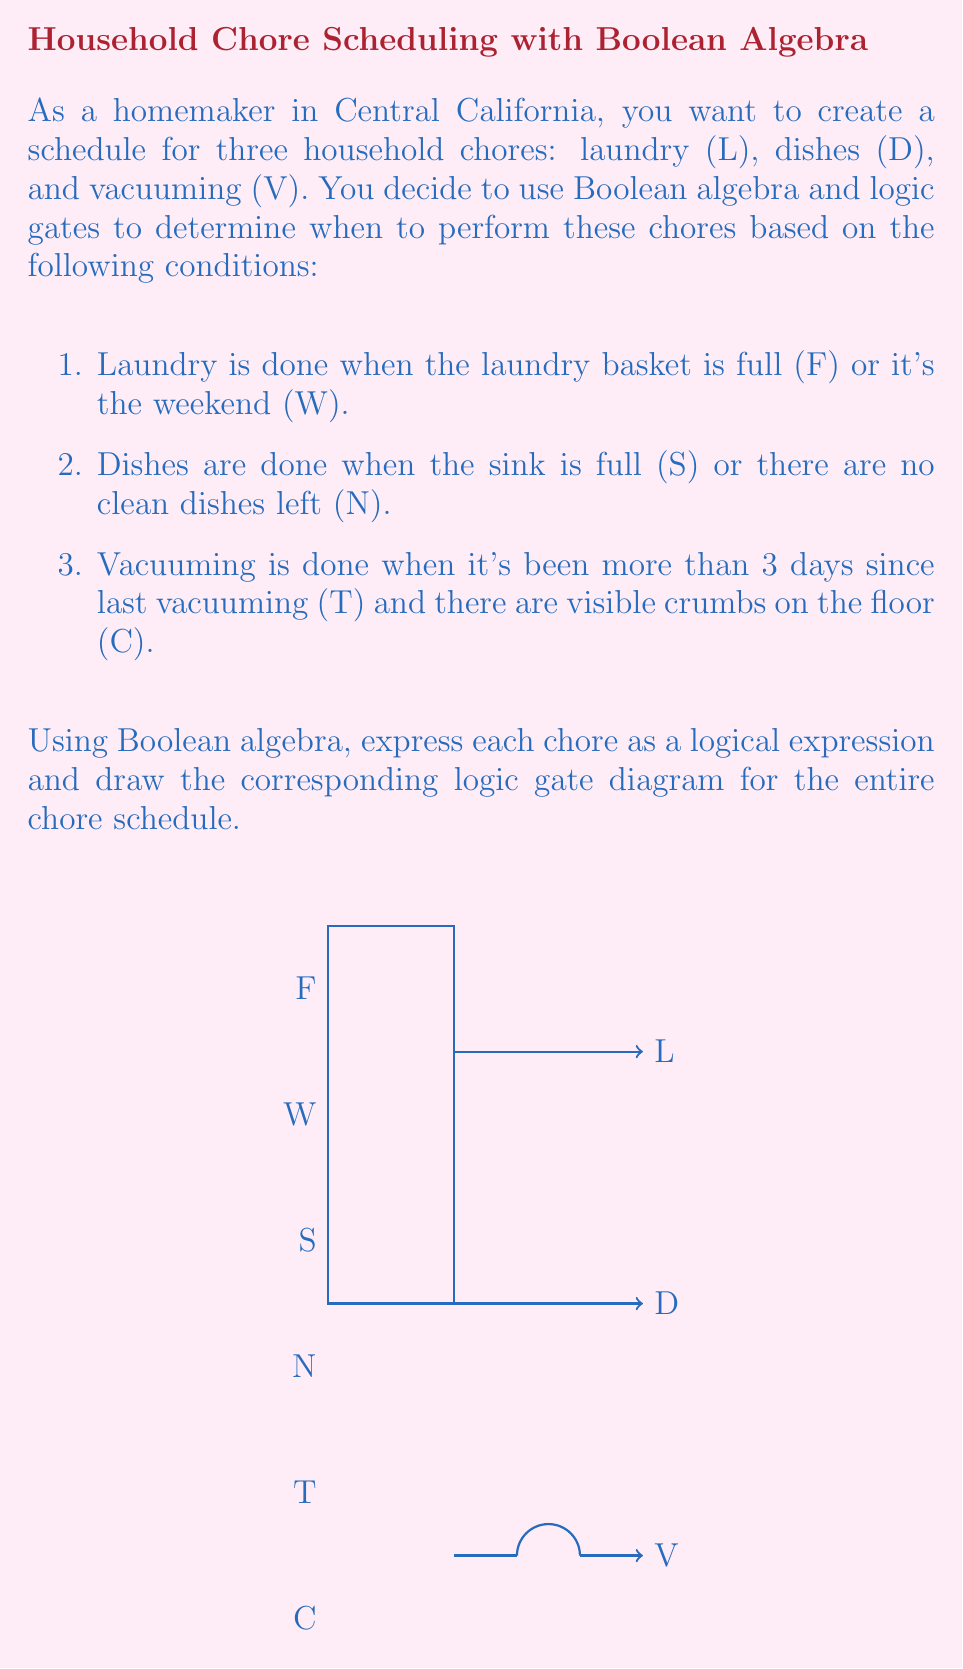What is the answer to this math problem? Let's break this down step-by-step:

1. For laundry (L):
   The condition is "laundry basket is full (F) OR it's the weekend (W)"
   This can be expressed as: $L = F + W$ (where + represents the OR operation)

2. For dishes (D):
   The condition is "sink is full (S) OR there are no clean dishes left (N)"
   This can be expressed as: $D = S + N$

3. For vacuuming (V):
   The condition is "more than 3 days since last vacuuming (T) AND there are visible crumbs on the floor (C)"
   This can be expressed as: $V = T \cdot C$ (where · represents the AND operation)

The complete Boolean expression for the chore schedule is:
$$(F + W) + (S + N) + (T \cdot C)$$

In the diagram:
- The OR gates are represented by the curved lines joining at a point.
- The AND gate is represented by the straight line with a curved input.
- The inputs F, W, S, N, T, and C are on the left.
- The outputs L, D, and V are on the right.

This diagram represents the logical structure of your chore schedule, where each chore (L, D, V) will be performed when its corresponding logical condition is true.
Answer: $L = F + W$, $D = S + N$, $V = T \cdot C$ 